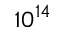Convert formula to latex. <formula><loc_0><loc_0><loc_500><loc_500>1 0 ^ { 1 4 }</formula> 